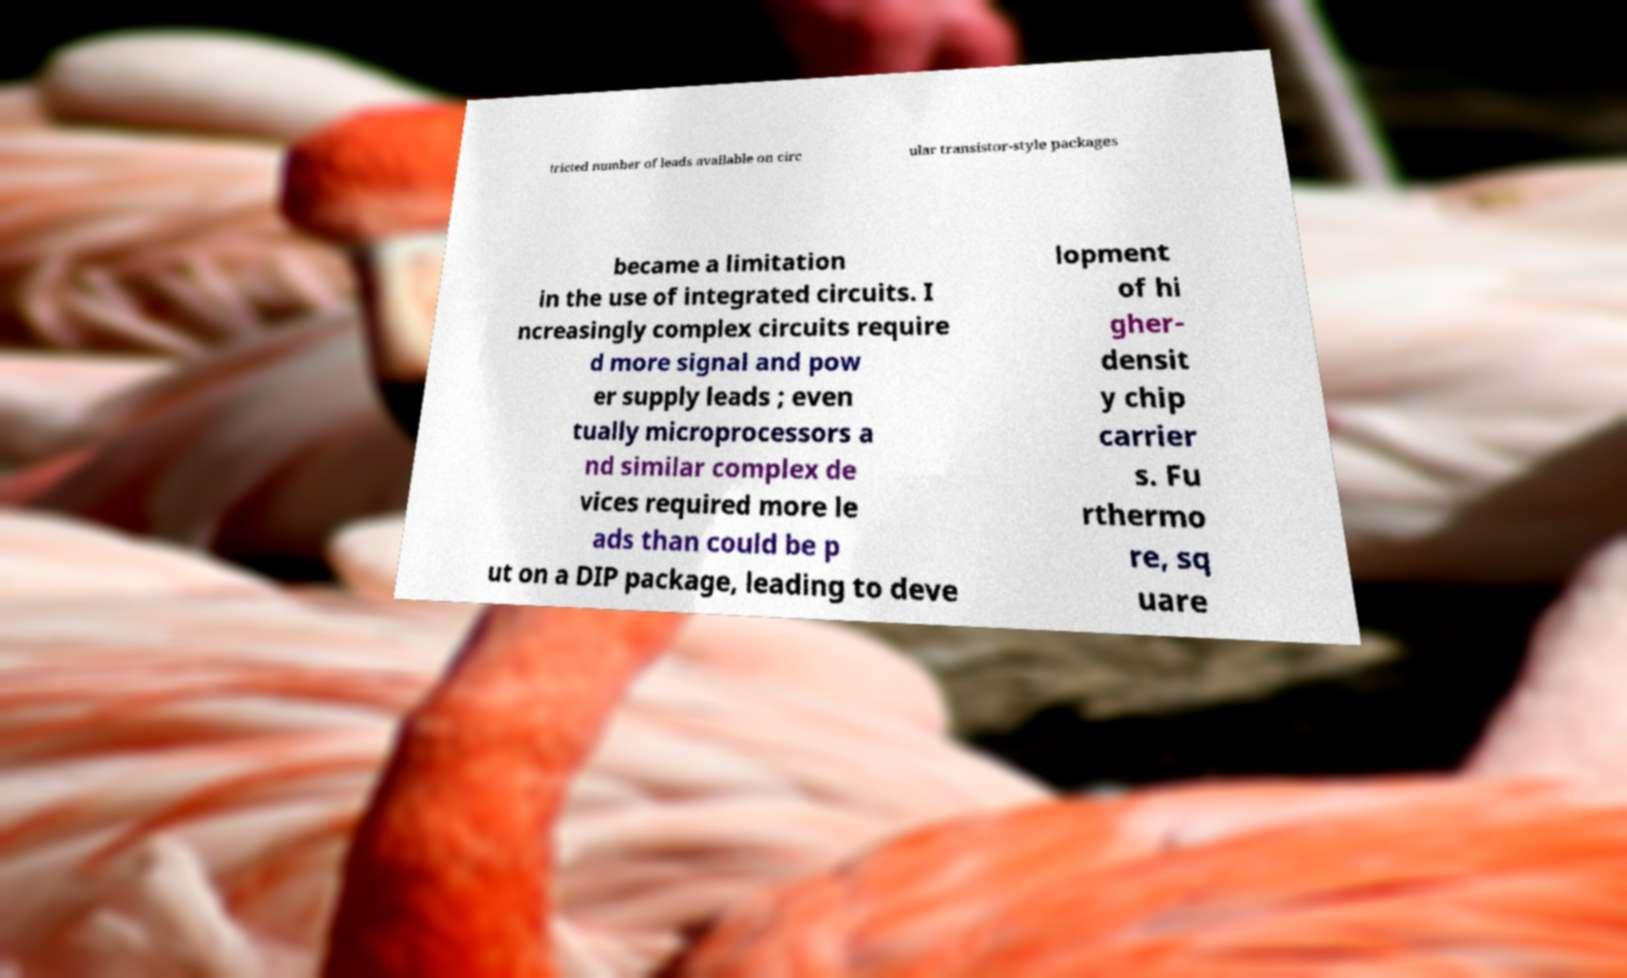Can you read and provide the text displayed in the image?This photo seems to have some interesting text. Can you extract and type it out for me? tricted number of leads available on circ ular transistor-style packages became a limitation in the use of integrated circuits. I ncreasingly complex circuits require d more signal and pow er supply leads ; even tually microprocessors a nd similar complex de vices required more le ads than could be p ut on a DIP package, leading to deve lopment of hi gher- densit y chip carrier s. Fu rthermo re, sq uare 